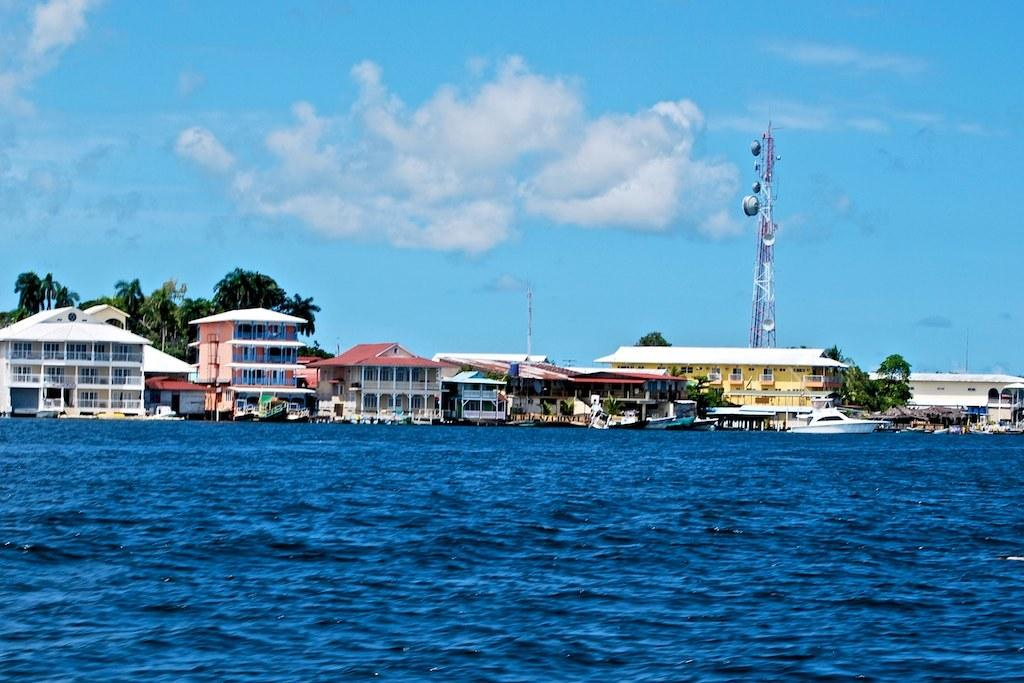What is in the front of the image? There is water in the front of the image. What can be seen in the background of the image? There are buildings, a tower, and trees in the background of the image. How would you describe the sky in the image? The sky is cloudy in the image. How many babies are playing in the water in the image? There are no babies present in the image; it features water in the front and various structures in the background. What season is depicted in the image? The provided facts do not mention any specific season, so it cannot be determined from the image. 